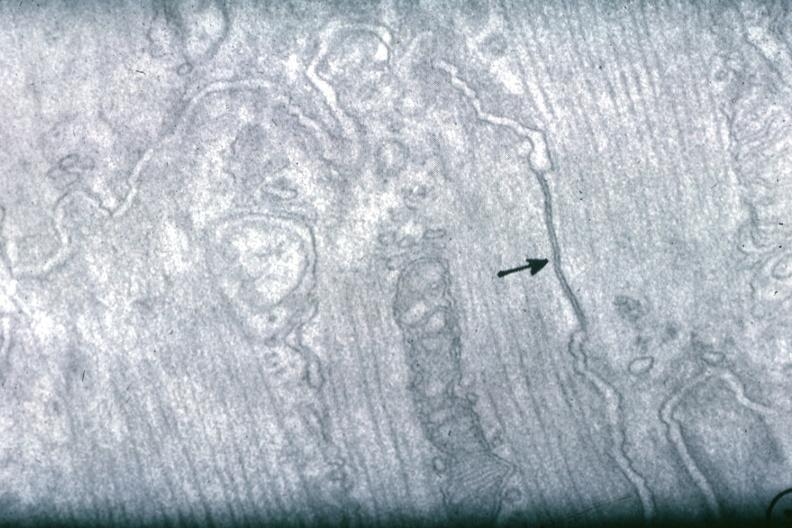does this image show junctional complex between two cells?
Answer the question using a single word or phrase. Yes 